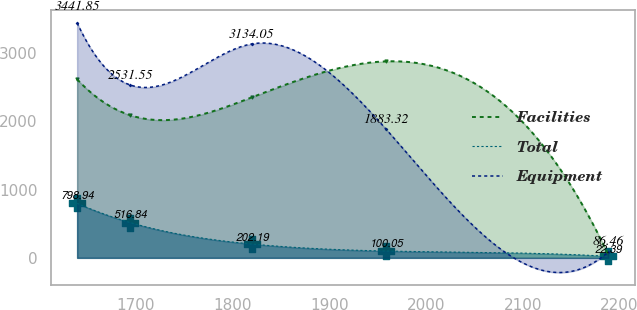Convert chart to OTSL. <chart><loc_0><loc_0><loc_500><loc_500><line_chart><ecel><fcel>Facilities<fcel>Total<fcel>Equipment<nl><fcel>1639.68<fcel>2614.89<fcel>798.94<fcel>3441.85<nl><fcel>1694.62<fcel>2088.93<fcel>516.84<fcel>2531.55<nl><fcel>1820.32<fcel>2351.91<fcel>202.19<fcel>3134.05<nl><fcel>1958.89<fcel>2877.87<fcel>100.05<fcel>1883.32<nl><fcel>2188.28<fcel>48.37<fcel>22.39<fcel>86.46<nl></chart> 